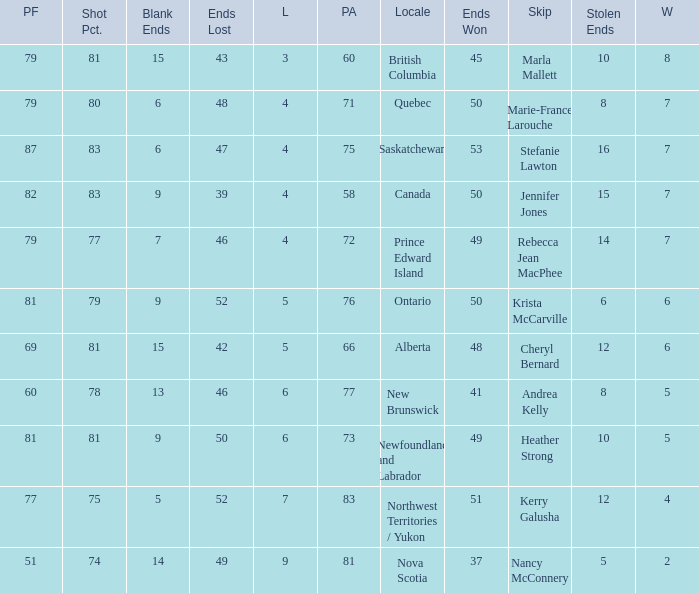What is the pf for Rebecca Jean Macphee? 79.0. 